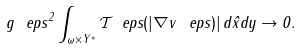<formula> <loc_0><loc_0><loc_500><loc_500>g \ e p s ^ { 2 } \int _ { \omega \times Y ^ { * } } \mathcal { T } _ { \ } e p s ( | \nabla { v ^ { \ } e p s } ) | \, d { \hat { x } } d { y } \to 0 .</formula> 